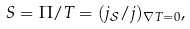<formula> <loc_0><loc_0><loc_500><loc_500>S = \Pi / T = ( j _ { \mathcal { S } } / j ) _ { \nabla T = 0 } ,</formula> 